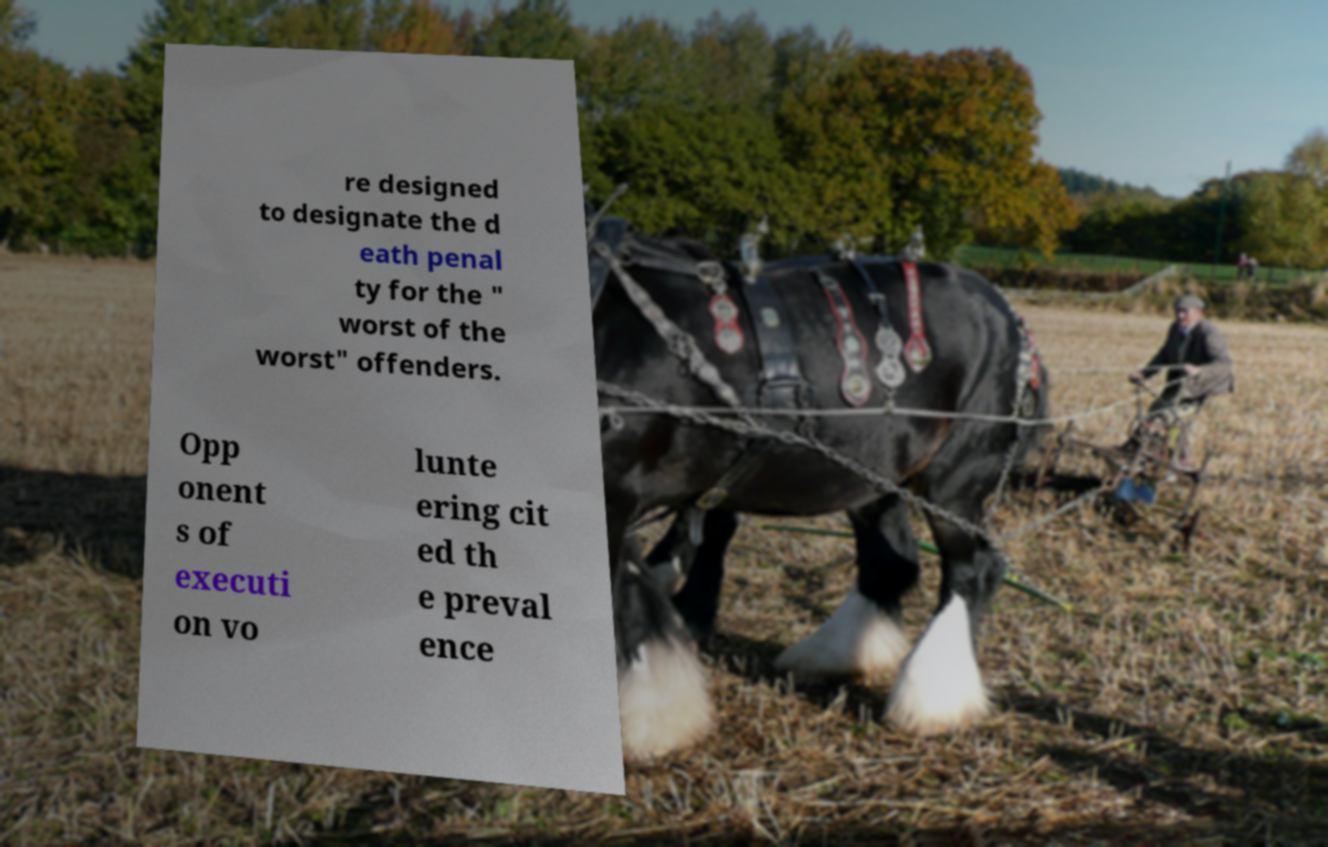What messages or text are displayed in this image? I need them in a readable, typed format. re designed to designate the d eath penal ty for the " worst of the worst" offenders. Opp onent s of executi on vo lunte ering cit ed th e preval ence 